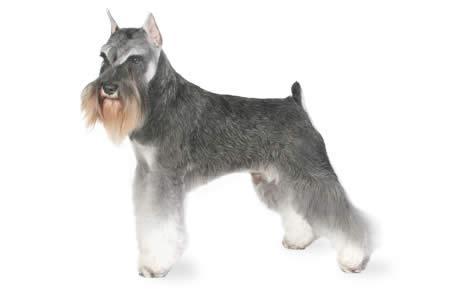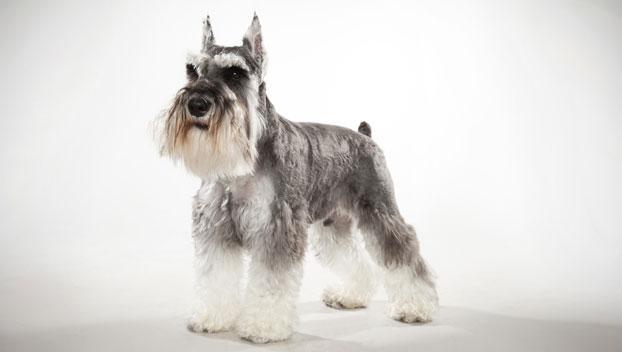The first image is the image on the left, the second image is the image on the right. For the images displayed, is the sentence "At least one image is a solo black dog." factually correct? Answer yes or no. No. 